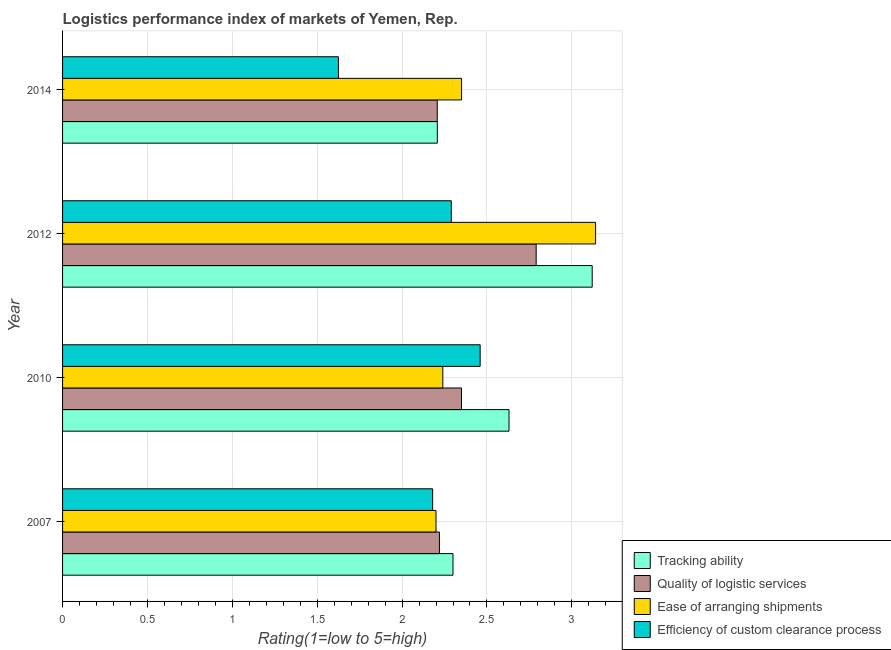How many different coloured bars are there?
Make the answer very short. 4. Are the number of bars per tick equal to the number of legend labels?
Keep it short and to the point. Yes. Are the number of bars on each tick of the Y-axis equal?
Your answer should be very brief. Yes. How many bars are there on the 4th tick from the top?
Provide a short and direct response. 4. How many bars are there on the 1st tick from the bottom?
Your response must be concise. 4. What is the label of the 3rd group of bars from the top?
Provide a short and direct response. 2010. In how many cases, is the number of bars for a given year not equal to the number of legend labels?
Offer a terse response. 0. What is the lpi rating of ease of arranging shipments in 2014?
Ensure brevity in your answer.  2.35. Across all years, what is the maximum lpi rating of efficiency of custom clearance process?
Ensure brevity in your answer.  2.46. Across all years, what is the minimum lpi rating of efficiency of custom clearance process?
Keep it short and to the point. 1.62. In which year was the lpi rating of quality of logistic services maximum?
Make the answer very short. 2012. In which year was the lpi rating of efficiency of custom clearance process minimum?
Ensure brevity in your answer.  2014. What is the total lpi rating of ease of arranging shipments in the graph?
Provide a short and direct response. 9.93. What is the difference between the lpi rating of efficiency of custom clearance process in 2010 and that in 2014?
Give a very brief answer. 0.83. What is the difference between the lpi rating of efficiency of custom clearance process in 2014 and the lpi rating of ease of arranging shipments in 2007?
Keep it short and to the point. -0.58. What is the average lpi rating of ease of arranging shipments per year?
Offer a very short reply. 2.48. In the year 2014, what is the difference between the lpi rating of tracking ability and lpi rating of quality of logistic services?
Provide a short and direct response. 0. In how many years, is the lpi rating of ease of arranging shipments greater than 1.1 ?
Provide a short and direct response. 4. What is the ratio of the lpi rating of quality of logistic services in 2010 to that in 2012?
Your answer should be compact. 0.84. Is the difference between the lpi rating of efficiency of custom clearance process in 2007 and 2010 greater than the difference between the lpi rating of tracking ability in 2007 and 2010?
Provide a succinct answer. Yes. What is the difference between the highest and the second highest lpi rating of ease of arranging shipments?
Give a very brief answer. 0.79. What is the difference between the highest and the lowest lpi rating of quality of logistic services?
Offer a very short reply. 0.58. Is the sum of the lpi rating of efficiency of custom clearance process in 2010 and 2014 greater than the maximum lpi rating of ease of arranging shipments across all years?
Keep it short and to the point. Yes. What does the 3rd bar from the top in 2012 represents?
Provide a short and direct response. Quality of logistic services. What does the 3rd bar from the bottom in 2012 represents?
Provide a short and direct response. Ease of arranging shipments. Is it the case that in every year, the sum of the lpi rating of tracking ability and lpi rating of quality of logistic services is greater than the lpi rating of ease of arranging shipments?
Make the answer very short. Yes. Are all the bars in the graph horizontal?
Provide a short and direct response. Yes. How many years are there in the graph?
Your answer should be very brief. 4. Does the graph contain grids?
Keep it short and to the point. Yes. Where does the legend appear in the graph?
Offer a very short reply. Bottom right. How many legend labels are there?
Provide a short and direct response. 4. What is the title of the graph?
Your answer should be compact. Logistics performance index of markets of Yemen, Rep. What is the label or title of the X-axis?
Offer a very short reply. Rating(1=low to 5=high). What is the Rating(1=low to 5=high) in Quality of logistic services in 2007?
Provide a succinct answer. 2.22. What is the Rating(1=low to 5=high) in Efficiency of custom clearance process in 2007?
Offer a terse response. 2.18. What is the Rating(1=low to 5=high) of Tracking ability in 2010?
Ensure brevity in your answer.  2.63. What is the Rating(1=low to 5=high) of Quality of logistic services in 2010?
Ensure brevity in your answer.  2.35. What is the Rating(1=low to 5=high) of Ease of arranging shipments in 2010?
Offer a very short reply. 2.24. What is the Rating(1=low to 5=high) of Efficiency of custom clearance process in 2010?
Your answer should be very brief. 2.46. What is the Rating(1=low to 5=high) in Tracking ability in 2012?
Keep it short and to the point. 3.12. What is the Rating(1=low to 5=high) in Quality of logistic services in 2012?
Ensure brevity in your answer.  2.79. What is the Rating(1=low to 5=high) in Ease of arranging shipments in 2012?
Your answer should be very brief. 3.14. What is the Rating(1=low to 5=high) in Efficiency of custom clearance process in 2012?
Offer a very short reply. 2.29. What is the Rating(1=low to 5=high) in Tracking ability in 2014?
Provide a succinct answer. 2.21. What is the Rating(1=low to 5=high) of Quality of logistic services in 2014?
Offer a very short reply. 2.21. What is the Rating(1=low to 5=high) in Ease of arranging shipments in 2014?
Keep it short and to the point. 2.35. What is the Rating(1=low to 5=high) in Efficiency of custom clearance process in 2014?
Make the answer very short. 1.62. Across all years, what is the maximum Rating(1=low to 5=high) in Tracking ability?
Your response must be concise. 3.12. Across all years, what is the maximum Rating(1=low to 5=high) of Quality of logistic services?
Your answer should be very brief. 2.79. Across all years, what is the maximum Rating(1=low to 5=high) in Ease of arranging shipments?
Ensure brevity in your answer.  3.14. Across all years, what is the maximum Rating(1=low to 5=high) of Efficiency of custom clearance process?
Make the answer very short. 2.46. Across all years, what is the minimum Rating(1=low to 5=high) in Tracking ability?
Provide a succinct answer. 2.21. Across all years, what is the minimum Rating(1=low to 5=high) in Quality of logistic services?
Offer a terse response. 2.21. Across all years, what is the minimum Rating(1=low to 5=high) of Ease of arranging shipments?
Your response must be concise. 2.2. Across all years, what is the minimum Rating(1=low to 5=high) of Efficiency of custom clearance process?
Make the answer very short. 1.62. What is the total Rating(1=low to 5=high) in Tracking ability in the graph?
Provide a succinct answer. 10.26. What is the total Rating(1=low to 5=high) in Quality of logistic services in the graph?
Ensure brevity in your answer.  9.57. What is the total Rating(1=low to 5=high) of Ease of arranging shipments in the graph?
Your answer should be very brief. 9.93. What is the total Rating(1=low to 5=high) of Efficiency of custom clearance process in the graph?
Offer a terse response. 8.55. What is the difference between the Rating(1=low to 5=high) of Tracking ability in 2007 and that in 2010?
Make the answer very short. -0.33. What is the difference between the Rating(1=low to 5=high) of Quality of logistic services in 2007 and that in 2010?
Provide a short and direct response. -0.13. What is the difference between the Rating(1=low to 5=high) of Ease of arranging shipments in 2007 and that in 2010?
Give a very brief answer. -0.04. What is the difference between the Rating(1=low to 5=high) of Efficiency of custom clearance process in 2007 and that in 2010?
Offer a terse response. -0.28. What is the difference between the Rating(1=low to 5=high) in Tracking ability in 2007 and that in 2012?
Keep it short and to the point. -0.82. What is the difference between the Rating(1=low to 5=high) of Quality of logistic services in 2007 and that in 2012?
Your answer should be compact. -0.57. What is the difference between the Rating(1=low to 5=high) of Ease of arranging shipments in 2007 and that in 2012?
Your answer should be very brief. -0.94. What is the difference between the Rating(1=low to 5=high) of Efficiency of custom clearance process in 2007 and that in 2012?
Offer a terse response. -0.11. What is the difference between the Rating(1=low to 5=high) in Tracking ability in 2007 and that in 2014?
Give a very brief answer. 0.09. What is the difference between the Rating(1=low to 5=high) in Quality of logistic services in 2007 and that in 2014?
Your answer should be very brief. 0.01. What is the difference between the Rating(1=low to 5=high) in Ease of arranging shipments in 2007 and that in 2014?
Your response must be concise. -0.15. What is the difference between the Rating(1=low to 5=high) in Efficiency of custom clearance process in 2007 and that in 2014?
Your answer should be very brief. 0.56. What is the difference between the Rating(1=low to 5=high) in Tracking ability in 2010 and that in 2012?
Make the answer very short. -0.49. What is the difference between the Rating(1=low to 5=high) of Quality of logistic services in 2010 and that in 2012?
Give a very brief answer. -0.44. What is the difference between the Rating(1=low to 5=high) in Ease of arranging shipments in 2010 and that in 2012?
Provide a short and direct response. -0.9. What is the difference between the Rating(1=low to 5=high) of Efficiency of custom clearance process in 2010 and that in 2012?
Offer a very short reply. 0.17. What is the difference between the Rating(1=low to 5=high) of Tracking ability in 2010 and that in 2014?
Keep it short and to the point. 0.42. What is the difference between the Rating(1=low to 5=high) of Quality of logistic services in 2010 and that in 2014?
Your answer should be very brief. 0.14. What is the difference between the Rating(1=low to 5=high) of Ease of arranging shipments in 2010 and that in 2014?
Keep it short and to the point. -0.11. What is the difference between the Rating(1=low to 5=high) in Efficiency of custom clearance process in 2010 and that in 2014?
Ensure brevity in your answer.  0.83. What is the difference between the Rating(1=low to 5=high) in Tracking ability in 2012 and that in 2014?
Give a very brief answer. 0.91. What is the difference between the Rating(1=low to 5=high) of Quality of logistic services in 2012 and that in 2014?
Provide a succinct answer. 0.58. What is the difference between the Rating(1=low to 5=high) in Ease of arranging shipments in 2012 and that in 2014?
Keep it short and to the point. 0.79. What is the difference between the Rating(1=low to 5=high) of Efficiency of custom clearance process in 2012 and that in 2014?
Offer a very short reply. 0.67. What is the difference between the Rating(1=low to 5=high) in Tracking ability in 2007 and the Rating(1=low to 5=high) in Quality of logistic services in 2010?
Ensure brevity in your answer.  -0.05. What is the difference between the Rating(1=low to 5=high) in Tracking ability in 2007 and the Rating(1=low to 5=high) in Efficiency of custom clearance process in 2010?
Give a very brief answer. -0.16. What is the difference between the Rating(1=low to 5=high) in Quality of logistic services in 2007 and the Rating(1=low to 5=high) in Ease of arranging shipments in 2010?
Your answer should be very brief. -0.02. What is the difference between the Rating(1=low to 5=high) in Quality of logistic services in 2007 and the Rating(1=low to 5=high) in Efficiency of custom clearance process in 2010?
Give a very brief answer. -0.24. What is the difference between the Rating(1=low to 5=high) in Ease of arranging shipments in 2007 and the Rating(1=low to 5=high) in Efficiency of custom clearance process in 2010?
Ensure brevity in your answer.  -0.26. What is the difference between the Rating(1=low to 5=high) in Tracking ability in 2007 and the Rating(1=low to 5=high) in Quality of logistic services in 2012?
Provide a succinct answer. -0.49. What is the difference between the Rating(1=low to 5=high) of Tracking ability in 2007 and the Rating(1=low to 5=high) of Ease of arranging shipments in 2012?
Your answer should be very brief. -0.84. What is the difference between the Rating(1=low to 5=high) in Tracking ability in 2007 and the Rating(1=low to 5=high) in Efficiency of custom clearance process in 2012?
Offer a terse response. 0.01. What is the difference between the Rating(1=low to 5=high) of Quality of logistic services in 2007 and the Rating(1=low to 5=high) of Ease of arranging shipments in 2012?
Your answer should be very brief. -0.92. What is the difference between the Rating(1=low to 5=high) in Quality of logistic services in 2007 and the Rating(1=low to 5=high) in Efficiency of custom clearance process in 2012?
Ensure brevity in your answer.  -0.07. What is the difference between the Rating(1=low to 5=high) in Ease of arranging shipments in 2007 and the Rating(1=low to 5=high) in Efficiency of custom clearance process in 2012?
Your response must be concise. -0.09. What is the difference between the Rating(1=low to 5=high) of Tracking ability in 2007 and the Rating(1=low to 5=high) of Quality of logistic services in 2014?
Your response must be concise. 0.09. What is the difference between the Rating(1=low to 5=high) in Tracking ability in 2007 and the Rating(1=low to 5=high) in Ease of arranging shipments in 2014?
Your response must be concise. -0.05. What is the difference between the Rating(1=low to 5=high) in Tracking ability in 2007 and the Rating(1=low to 5=high) in Efficiency of custom clearance process in 2014?
Make the answer very short. 0.68. What is the difference between the Rating(1=low to 5=high) in Quality of logistic services in 2007 and the Rating(1=low to 5=high) in Ease of arranging shipments in 2014?
Offer a very short reply. -0.13. What is the difference between the Rating(1=low to 5=high) in Quality of logistic services in 2007 and the Rating(1=low to 5=high) in Efficiency of custom clearance process in 2014?
Provide a short and direct response. 0.59. What is the difference between the Rating(1=low to 5=high) of Ease of arranging shipments in 2007 and the Rating(1=low to 5=high) of Efficiency of custom clearance process in 2014?
Your answer should be compact. 0.57. What is the difference between the Rating(1=low to 5=high) of Tracking ability in 2010 and the Rating(1=low to 5=high) of Quality of logistic services in 2012?
Provide a short and direct response. -0.16. What is the difference between the Rating(1=low to 5=high) in Tracking ability in 2010 and the Rating(1=low to 5=high) in Ease of arranging shipments in 2012?
Your answer should be very brief. -0.51. What is the difference between the Rating(1=low to 5=high) in Tracking ability in 2010 and the Rating(1=low to 5=high) in Efficiency of custom clearance process in 2012?
Keep it short and to the point. 0.34. What is the difference between the Rating(1=low to 5=high) in Quality of logistic services in 2010 and the Rating(1=low to 5=high) in Ease of arranging shipments in 2012?
Offer a terse response. -0.79. What is the difference between the Rating(1=low to 5=high) of Quality of logistic services in 2010 and the Rating(1=low to 5=high) of Efficiency of custom clearance process in 2012?
Provide a short and direct response. 0.06. What is the difference between the Rating(1=low to 5=high) of Ease of arranging shipments in 2010 and the Rating(1=low to 5=high) of Efficiency of custom clearance process in 2012?
Give a very brief answer. -0.05. What is the difference between the Rating(1=low to 5=high) of Tracking ability in 2010 and the Rating(1=low to 5=high) of Quality of logistic services in 2014?
Give a very brief answer. 0.42. What is the difference between the Rating(1=low to 5=high) of Tracking ability in 2010 and the Rating(1=low to 5=high) of Ease of arranging shipments in 2014?
Keep it short and to the point. 0.28. What is the difference between the Rating(1=low to 5=high) of Quality of logistic services in 2010 and the Rating(1=low to 5=high) of Ease of arranging shipments in 2014?
Your answer should be compact. -0. What is the difference between the Rating(1=low to 5=high) in Quality of logistic services in 2010 and the Rating(1=low to 5=high) in Efficiency of custom clearance process in 2014?
Your response must be concise. 0.72. What is the difference between the Rating(1=low to 5=high) in Ease of arranging shipments in 2010 and the Rating(1=low to 5=high) in Efficiency of custom clearance process in 2014?
Give a very brief answer. 0.61. What is the difference between the Rating(1=low to 5=high) of Tracking ability in 2012 and the Rating(1=low to 5=high) of Quality of logistic services in 2014?
Give a very brief answer. 0.91. What is the difference between the Rating(1=low to 5=high) of Tracking ability in 2012 and the Rating(1=low to 5=high) of Ease of arranging shipments in 2014?
Offer a terse response. 0.77. What is the difference between the Rating(1=low to 5=high) in Tracking ability in 2012 and the Rating(1=low to 5=high) in Efficiency of custom clearance process in 2014?
Make the answer very short. 1.5. What is the difference between the Rating(1=low to 5=high) of Quality of logistic services in 2012 and the Rating(1=low to 5=high) of Ease of arranging shipments in 2014?
Offer a terse response. 0.44. What is the difference between the Rating(1=low to 5=high) of Quality of logistic services in 2012 and the Rating(1=low to 5=high) of Efficiency of custom clearance process in 2014?
Make the answer very short. 1.17. What is the difference between the Rating(1=low to 5=high) of Ease of arranging shipments in 2012 and the Rating(1=low to 5=high) of Efficiency of custom clearance process in 2014?
Keep it short and to the point. 1.51. What is the average Rating(1=low to 5=high) of Tracking ability per year?
Your answer should be very brief. 2.56. What is the average Rating(1=low to 5=high) of Quality of logistic services per year?
Make the answer very short. 2.39. What is the average Rating(1=low to 5=high) of Ease of arranging shipments per year?
Make the answer very short. 2.48. What is the average Rating(1=low to 5=high) of Efficiency of custom clearance process per year?
Your answer should be very brief. 2.14. In the year 2007, what is the difference between the Rating(1=low to 5=high) in Tracking ability and Rating(1=low to 5=high) in Quality of logistic services?
Your answer should be very brief. 0.08. In the year 2007, what is the difference between the Rating(1=low to 5=high) of Tracking ability and Rating(1=low to 5=high) of Efficiency of custom clearance process?
Keep it short and to the point. 0.12. In the year 2007, what is the difference between the Rating(1=low to 5=high) of Quality of logistic services and Rating(1=low to 5=high) of Ease of arranging shipments?
Provide a short and direct response. 0.02. In the year 2007, what is the difference between the Rating(1=low to 5=high) in Quality of logistic services and Rating(1=low to 5=high) in Efficiency of custom clearance process?
Offer a terse response. 0.04. In the year 2007, what is the difference between the Rating(1=low to 5=high) in Ease of arranging shipments and Rating(1=low to 5=high) in Efficiency of custom clearance process?
Your answer should be compact. 0.02. In the year 2010, what is the difference between the Rating(1=low to 5=high) of Tracking ability and Rating(1=low to 5=high) of Quality of logistic services?
Your response must be concise. 0.28. In the year 2010, what is the difference between the Rating(1=low to 5=high) of Tracking ability and Rating(1=low to 5=high) of Ease of arranging shipments?
Offer a very short reply. 0.39. In the year 2010, what is the difference between the Rating(1=low to 5=high) in Tracking ability and Rating(1=low to 5=high) in Efficiency of custom clearance process?
Ensure brevity in your answer.  0.17. In the year 2010, what is the difference between the Rating(1=low to 5=high) of Quality of logistic services and Rating(1=low to 5=high) of Ease of arranging shipments?
Provide a short and direct response. 0.11. In the year 2010, what is the difference between the Rating(1=low to 5=high) of Quality of logistic services and Rating(1=low to 5=high) of Efficiency of custom clearance process?
Your answer should be very brief. -0.11. In the year 2010, what is the difference between the Rating(1=low to 5=high) in Ease of arranging shipments and Rating(1=low to 5=high) in Efficiency of custom clearance process?
Provide a short and direct response. -0.22. In the year 2012, what is the difference between the Rating(1=low to 5=high) in Tracking ability and Rating(1=low to 5=high) in Quality of logistic services?
Make the answer very short. 0.33. In the year 2012, what is the difference between the Rating(1=low to 5=high) in Tracking ability and Rating(1=low to 5=high) in Ease of arranging shipments?
Make the answer very short. -0.02. In the year 2012, what is the difference between the Rating(1=low to 5=high) in Tracking ability and Rating(1=low to 5=high) in Efficiency of custom clearance process?
Your answer should be compact. 0.83. In the year 2012, what is the difference between the Rating(1=low to 5=high) in Quality of logistic services and Rating(1=low to 5=high) in Ease of arranging shipments?
Provide a succinct answer. -0.35. In the year 2012, what is the difference between the Rating(1=low to 5=high) of Quality of logistic services and Rating(1=low to 5=high) of Efficiency of custom clearance process?
Provide a succinct answer. 0.5. In the year 2014, what is the difference between the Rating(1=low to 5=high) in Tracking ability and Rating(1=low to 5=high) in Quality of logistic services?
Make the answer very short. 0. In the year 2014, what is the difference between the Rating(1=low to 5=high) of Tracking ability and Rating(1=low to 5=high) of Ease of arranging shipments?
Offer a terse response. -0.14. In the year 2014, what is the difference between the Rating(1=low to 5=high) of Tracking ability and Rating(1=low to 5=high) of Efficiency of custom clearance process?
Offer a very short reply. 0.58. In the year 2014, what is the difference between the Rating(1=low to 5=high) of Quality of logistic services and Rating(1=low to 5=high) of Ease of arranging shipments?
Provide a short and direct response. -0.14. In the year 2014, what is the difference between the Rating(1=low to 5=high) of Quality of logistic services and Rating(1=low to 5=high) of Efficiency of custom clearance process?
Provide a succinct answer. 0.58. In the year 2014, what is the difference between the Rating(1=low to 5=high) of Ease of arranging shipments and Rating(1=low to 5=high) of Efficiency of custom clearance process?
Offer a very short reply. 0.73. What is the ratio of the Rating(1=low to 5=high) in Tracking ability in 2007 to that in 2010?
Give a very brief answer. 0.87. What is the ratio of the Rating(1=low to 5=high) of Quality of logistic services in 2007 to that in 2010?
Offer a terse response. 0.94. What is the ratio of the Rating(1=low to 5=high) in Ease of arranging shipments in 2007 to that in 2010?
Offer a terse response. 0.98. What is the ratio of the Rating(1=low to 5=high) of Efficiency of custom clearance process in 2007 to that in 2010?
Give a very brief answer. 0.89. What is the ratio of the Rating(1=low to 5=high) in Tracking ability in 2007 to that in 2012?
Offer a terse response. 0.74. What is the ratio of the Rating(1=low to 5=high) of Quality of logistic services in 2007 to that in 2012?
Ensure brevity in your answer.  0.8. What is the ratio of the Rating(1=low to 5=high) in Ease of arranging shipments in 2007 to that in 2012?
Your response must be concise. 0.7. What is the ratio of the Rating(1=low to 5=high) of Efficiency of custom clearance process in 2007 to that in 2012?
Provide a short and direct response. 0.95. What is the ratio of the Rating(1=low to 5=high) in Tracking ability in 2007 to that in 2014?
Keep it short and to the point. 1.04. What is the ratio of the Rating(1=low to 5=high) of Quality of logistic services in 2007 to that in 2014?
Your response must be concise. 1.01. What is the ratio of the Rating(1=low to 5=high) of Ease of arranging shipments in 2007 to that in 2014?
Your response must be concise. 0.94. What is the ratio of the Rating(1=low to 5=high) of Efficiency of custom clearance process in 2007 to that in 2014?
Your answer should be compact. 1.34. What is the ratio of the Rating(1=low to 5=high) in Tracking ability in 2010 to that in 2012?
Your answer should be compact. 0.84. What is the ratio of the Rating(1=low to 5=high) in Quality of logistic services in 2010 to that in 2012?
Give a very brief answer. 0.84. What is the ratio of the Rating(1=low to 5=high) in Ease of arranging shipments in 2010 to that in 2012?
Your response must be concise. 0.71. What is the ratio of the Rating(1=low to 5=high) in Efficiency of custom clearance process in 2010 to that in 2012?
Provide a succinct answer. 1.07. What is the ratio of the Rating(1=low to 5=high) of Tracking ability in 2010 to that in 2014?
Provide a succinct answer. 1.19. What is the ratio of the Rating(1=low to 5=high) of Quality of logistic services in 2010 to that in 2014?
Keep it short and to the point. 1.06. What is the ratio of the Rating(1=low to 5=high) of Ease of arranging shipments in 2010 to that in 2014?
Provide a succinct answer. 0.95. What is the ratio of the Rating(1=low to 5=high) of Efficiency of custom clearance process in 2010 to that in 2014?
Your answer should be compact. 1.51. What is the ratio of the Rating(1=low to 5=high) of Tracking ability in 2012 to that in 2014?
Your answer should be compact. 1.41. What is the ratio of the Rating(1=low to 5=high) of Quality of logistic services in 2012 to that in 2014?
Keep it short and to the point. 1.26. What is the ratio of the Rating(1=low to 5=high) in Ease of arranging shipments in 2012 to that in 2014?
Keep it short and to the point. 1.34. What is the ratio of the Rating(1=low to 5=high) of Efficiency of custom clearance process in 2012 to that in 2014?
Make the answer very short. 1.41. What is the difference between the highest and the second highest Rating(1=low to 5=high) in Tracking ability?
Your answer should be very brief. 0.49. What is the difference between the highest and the second highest Rating(1=low to 5=high) of Quality of logistic services?
Make the answer very short. 0.44. What is the difference between the highest and the second highest Rating(1=low to 5=high) in Ease of arranging shipments?
Your answer should be very brief. 0.79. What is the difference between the highest and the second highest Rating(1=low to 5=high) in Efficiency of custom clearance process?
Your answer should be compact. 0.17. What is the difference between the highest and the lowest Rating(1=low to 5=high) in Tracking ability?
Offer a terse response. 0.91. What is the difference between the highest and the lowest Rating(1=low to 5=high) of Quality of logistic services?
Your response must be concise. 0.58. What is the difference between the highest and the lowest Rating(1=low to 5=high) in Ease of arranging shipments?
Your answer should be very brief. 0.94. What is the difference between the highest and the lowest Rating(1=low to 5=high) in Efficiency of custom clearance process?
Offer a very short reply. 0.83. 